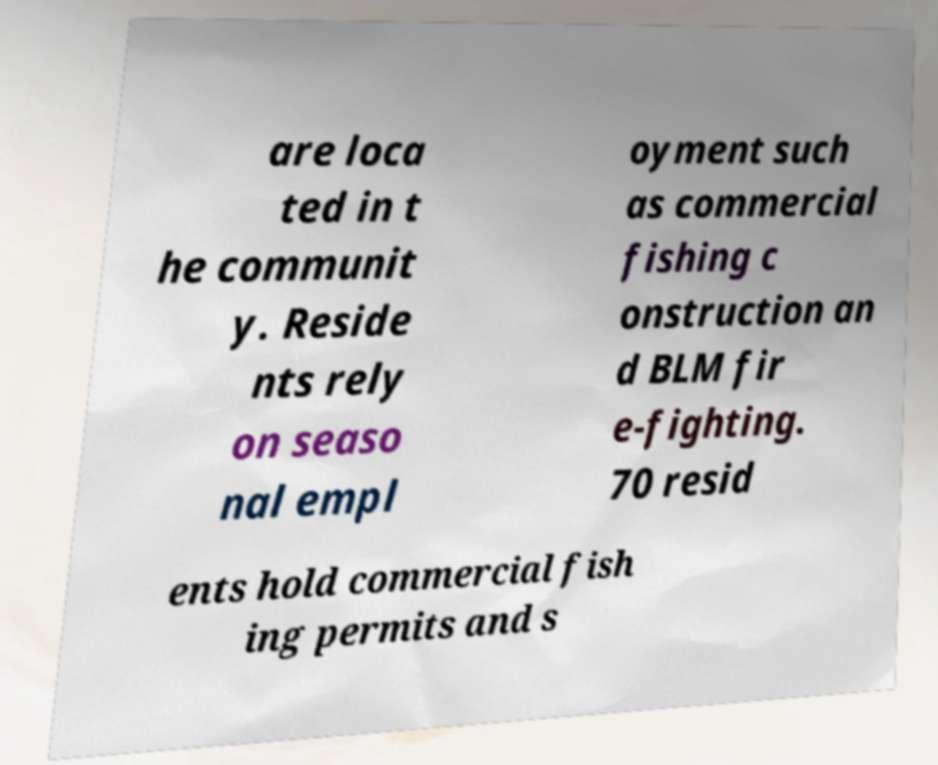Could you assist in decoding the text presented in this image and type it out clearly? are loca ted in t he communit y. Reside nts rely on seaso nal empl oyment such as commercial fishing c onstruction an d BLM fir e-fighting. 70 resid ents hold commercial fish ing permits and s 